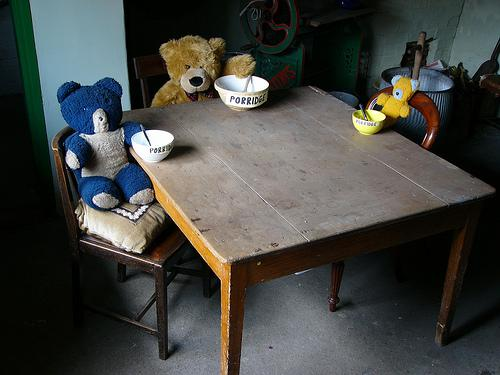Question: what are the bowls on?
Choices:
A. Counter.
B. Desk.
C. Table.
D. Patio.
Answer with the letter. Answer: C Question: how many bears?
Choices:
A. 6.
B. 3.
C. 4.
D. 5.
Answer with the letter. Answer: B 